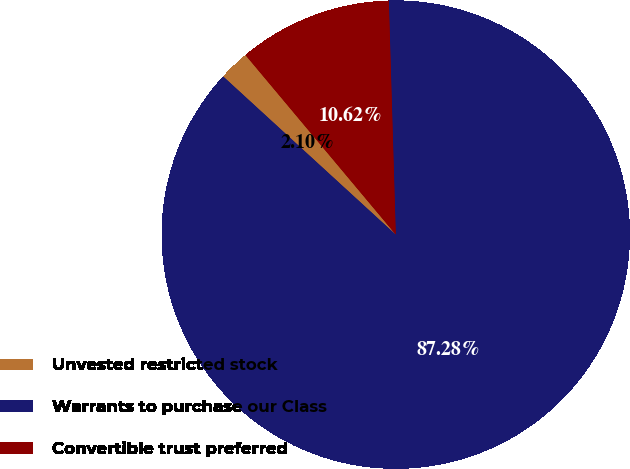<chart> <loc_0><loc_0><loc_500><loc_500><pie_chart><fcel>Unvested restricted stock<fcel>Warrants to purchase our Class<fcel>Convertible trust preferred<nl><fcel>2.1%<fcel>87.28%<fcel>10.62%<nl></chart> 